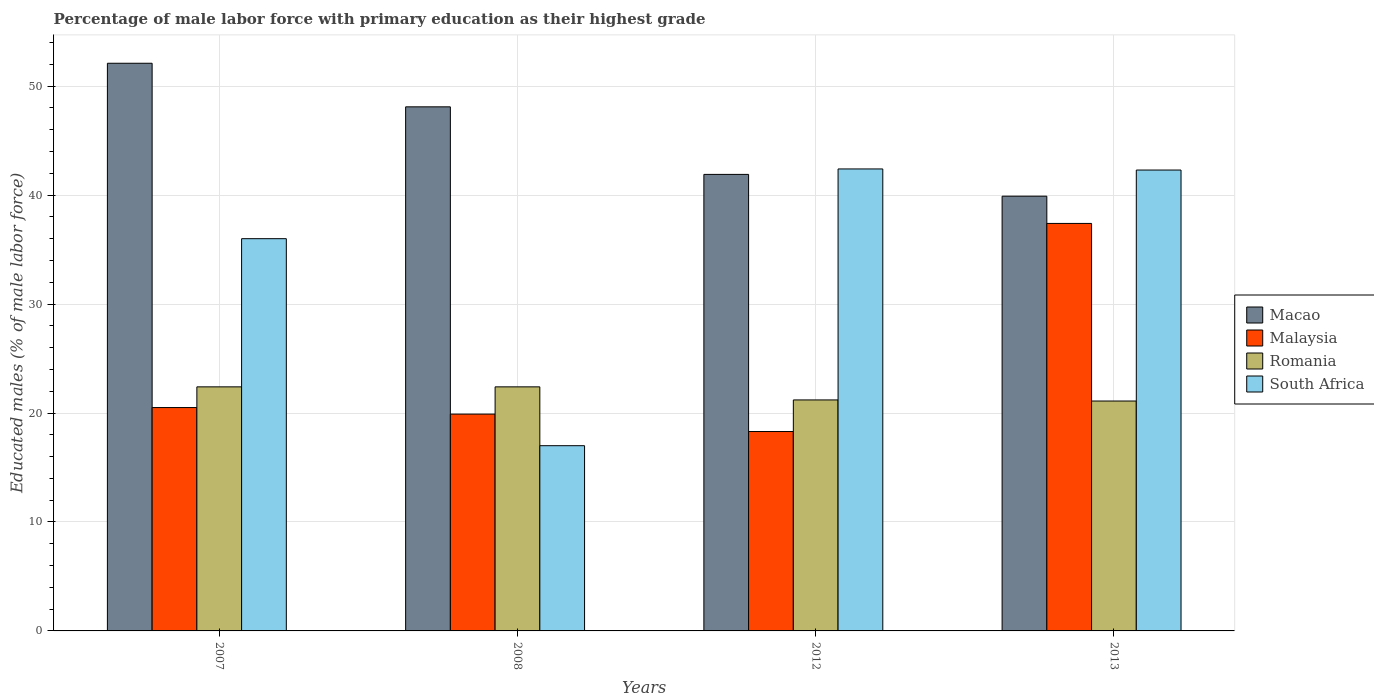Are the number of bars per tick equal to the number of legend labels?
Make the answer very short. Yes. How many bars are there on the 1st tick from the left?
Offer a terse response. 4. What is the label of the 1st group of bars from the left?
Offer a very short reply. 2007. What is the percentage of male labor force with primary education in South Africa in 2012?
Offer a terse response. 42.4. Across all years, what is the maximum percentage of male labor force with primary education in Malaysia?
Your answer should be compact. 37.4. Across all years, what is the minimum percentage of male labor force with primary education in Romania?
Your answer should be compact. 21.1. In which year was the percentage of male labor force with primary education in South Africa maximum?
Your answer should be very brief. 2012. In which year was the percentage of male labor force with primary education in South Africa minimum?
Offer a terse response. 2008. What is the total percentage of male labor force with primary education in Romania in the graph?
Ensure brevity in your answer.  87.1. What is the difference between the percentage of male labor force with primary education in South Africa in 2012 and that in 2013?
Make the answer very short. 0.1. What is the difference between the percentage of male labor force with primary education in Macao in 2007 and the percentage of male labor force with primary education in Malaysia in 2012?
Give a very brief answer. 33.8. What is the average percentage of male labor force with primary education in Malaysia per year?
Provide a short and direct response. 24.03. In the year 2008, what is the difference between the percentage of male labor force with primary education in Romania and percentage of male labor force with primary education in Macao?
Keep it short and to the point. -25.7. What is the ratio of the percentage of male labor force with primary education in South Africa in 2007 to that in 2013?
Your answer should be compact. 0.85. What is the difference between the highest and the lowest percentage of male labor force with primary education in Romania?
Your answer should be compact. 1.3. Is the sum of the percentage of male labor force with primary education in Malaysia in 2008 and 2013 greater than the maximum percentage of male labor force with primary education in Macao across all years?
Provide a short and direct response. Yes. Is it the case that in every year, the sum of the percentage of male labor force with primary education in Malaysia and percentage of male labor force with primary education in Romania is greater than the sum of percentage of male labor force with primary education in South Africa and percentage of male labor force with primary education in Macao?
Give a very brief answer. No. What does the 3rd bar from the left in 2012 represents?
Offer a very short reply. Romania. What does the 1st bar from the right in 2013 represents?
Provide a succinct answer. South Africa. How many bars are there?
Your response must be concise. 16. How many years are there in the graph?
Your response must be concise. 4. What is the difference between two consecutive major ticks on the Y-axis?
Ensure brevity in your answer.  10. Are the values on the major ticks of Y-axis written in scientific E-notation?
Your answer should be very brief. No. Does the graph contain grids?
Your answer should be compact. Yes. Where does the legend appear in the graph?
Ensure brevity in your answer.  Center right. How are the legend labels stacked?
Provide a succinct answer. Vertical. What is the title of the graph?
Provide a short and direct response. Percentage of male labor force with primary education as their highest grade. What is the label or title of the Y-axis?
Ensure brevity in your answer.  Educated males (% of male labor force). What is the Educated males (% of male labor force) of Macao in 2007?
Make the answer very short. 52.1. What is the Educated males (% of male labor force) of Romania in 2007?
Offer a very short reply. 22.4. What is the Educated males (% of male labor force) in Macao in 2008?
Offer a very short reply. 48.1. What is the Educated males (% of male labor force) in Malaysia in 2008?
Offer a terse response. 19.9. What is the Educated males (% of male labor force) of Romania in 2008?
Your answer should be compact. 22.4. What is the Educated males (% of male labor force) of South Africa in 2008?
Provide a short and direct response. 17. What is the Educated males (% of male labor force) in Macao in 2012?
Provide a succinct answer. 41.9. What is the Educated males (% of male labor force) of Malaysia in 2012?
Offer a terse response. 18.3. What is the Educated males (% of male labor force) of Romania in 2012?
Ensure brevity in your answer.  21.2. What is the Educated males (% of male labor force) of South Africa in 2012?
Your answer should be very brief. 42.4. What is the Educated males (% of male labor force) of Macao in 2013?
Offer a terse response. 39.9. What is the Educated males (% of male labor force) of Malaysia in 2013?
Make the answer very short. 37.4. What is the Educated males (% of male labor force) in Romania in 2013?
Your answer should be very brief. 21.1. What is the Educated males (% of male labor force) in South Africa in 2013?
Your answer should be very brief. 42.3. Across all years, what is the maximum Educated males (% of male labor force) of Macao?
Give a very brief answer. 52.1. Across all years, what is the maximum Educated males (% of male labor force) in Malaysia?
Your response must be concise. 37.4. Across all years, what is the maximum Educated males (% of male labor force) in Romania?
Make the answer very short. 22.4. Across all years, what is the maximum Educated males (% of male labor force) in South Africa?
Keep it short and to the point. 42.4. Across all years, what is the minimum Educated males (% of male labor force) of Macao?
Your answer should be very brief. 39.9. Across all years, what is the minimum Educated males (% of male labor force) of Malaysia?
Provide a succinct answer. 18.3. Across all years, what is the minimum Educated males (% of male labor force) in Romania?
Provide a succinct answer. 21.1. What is the total Educated males (% of male labor force) in Macao in the graph?
Give a very brief answer. 182. What is the total Educated males (% of male labor force) in Malaysia in the graph?
Give a very brief answer. 96.1. What is the total Educated males (% of male labor force) in Romania in the graph?
Keep it short and to the point. 87.1. What is the total Educated males (% of male labor force) of South Africa in the graph?
Give a very brief answer. 137.7. What is the difference between the Educated males (% of male labor force) in Macao in 2007 and that in 2008?
Offer a very short reply. 4. What is the difference between the Educated males (% of male labor force) in Malaysia in 2007 and that in 2012?
Your response must be concise. 2.2. What is the difference between the Educated males (% of male labor force) in Romania in 2007 and that in 2012?
Offer a terse response. 1.2. What is the difference between the Educated males (% of male labor force) of Malaysia in 2007 and that in 2013?
Your answer should be very brief. -16.9. What is the difference between the Educated males (% of male labor force) in Romania in 2007 and that in 2013?
Make the answer very short. 1.3. What is the difference between the Educated males (% of male labor force) in South Africa in 2007 and that in 2013?
Offer a very short reply. -6.3. What is the difference between the Educated males (% of male labor force) of Malaysia in 2008 and that in 2012?
Ensure brevity in your answer.  1.6. What is the difference between the Educated males (% of male labor force) in Romania in 2008 and that in 2012?
Make the answer very short. 1.2. What is the difference between the Educated males (% of male labor force) in South Africa in 2008 and that in 2012?
Make the answer very short. -25.4. What is the difference between the Educated males (% of male labor force) of Macao in 2008 and that in 2013?
Ensure brevity in your answer.  8.2. What is the difference between the Educated males (% of male labor force) of Malaysia in 2008 and that in 2013?
Keep it short and to the point. -17.5. What is the difference between the Educated males (% of male labor force) of Romania in 2008 and that in 2013?
Your answer should be compact. 1.3. What is the difference between the Educated males (% of male labor force) of South Africa in 2008 and that in 2013?
Make the answer very short. -25.3. What is the difference between the Educated males (% of male labor force) in Malaysia in 2012 and that in 2013?
Offer a terse response. -19.1. What is the difference between the Educated males (% of male labor force) of South Africa in 2012 and that in 2013?
Offer a very short reply. 0.1. What is the difference between the Educated males (% of male labor force) of Macao in 2007 and the Educated males (% of male labor force) of Malaysia in 2008?
Your answer should be very brief. 32.2. What is the difference between the Educated males (% of male labor force) in Macao in 2007 and the Educated males (% of male labor force) in Romania in 2008?
Make the answer very short. 29.7. What is the difference between the Educated males (% of male labor force) of Macao in 2007 and the Educated males (% of male labor force) of South Africa in 2008?
Provide a succinct answer. 35.1. What is the difference between the Educated males (% of male labor force) in Malaysia in 2007 and the Educated males (% of male labor force) in Romania in 2008?
Your answer should be very brief. -1.9. What is the difference between the Educated males (% of male labor force) in Malaysia in 2007 and the Educated males (% of male labor force) in South Africa in 2008?
Make the answer very short. 3.5. What is the difference between the Educated males (% of male labor force) in Romania in 2007 and the Educated males (% of male labor force) in South Africa in 2008?
Your answer should be compact. 5.4. What is the difference between the Educated males (% of male labor force) in Macao in 2007 and the Educated males (% of male labor force) in Malaysia in 2012?
Your answer should be compact. 33.8. What is the difference between the Educated males (% of male labor force) in Macao in 2007 and the Educated males (% of male labor force) in Romania in 2012?
Keep it short and to the point. 30.9. What is the difference between the Educated males (% of male labor force) in Macao in 2007 and the Educated males (% of male labor force) in South Africa in 2012?
Offer a very short reply. 9.7. What is the difference between the Educated males (% of male labor force) in Malaysia in 2007 and the Educated males (% of male labor force) in South Africa in 2012?
Give a very brief answer. -21.9. What is the difference between the Educated males (% of male labor force) in Romania in 2007 and the Educated males (% of male labor force) in South Africa in 2012?
Offer a terse response. -20. What is the difference between the Educated males (% of male labor force) in Macao in 2007 and the Educated males (% of male labor force) in Malaysia in 2013?
Your response must be concise. 14.7. What is the difference between the Educated males (% of male labor force) of Macao in 2007 and the Educated males (% of male labor force) of Romania in 2013?
Keep it short and to the point. 31. What is the difference between the Educated males (% of male labor force) of Malaysia in 2007 and the Educated males (% of male labor force) of South Africa in 2013?
Ensure brevity in your answer.  -21.8. What is the difference between the Educated males (% of male labor force) of Romania in 2007 and the Educated males (% of male labor force) of South Africa in 2013?
Give a very brief answer. -19.9. What is the difference between the Educated males (% of male labor force) of Macao in 2008 and the Educated males (% of male labor force) of Malaysia in 2012?
Make the answer very short. 29.8. What is the difference between the Educated males (% of male labor force) of Macao in 2008 and the Educated males (% of male labor force) of Romania in 2012?
Give a very brief answer. 26.9. What is the difference between the Educated males (% of male labor force) of Malaysia in 2008 and the Educated males (% of male labor force) of Romania in 2012?
Ensure brevity in your answer.  -1.3. What is the difference between the Educated males (% of male labor force) in Malaysia in 2008 and the Educated males (% of male labor force) in South Africa in 2012?
Your answer should be compact. -22.5. What is the difference between the Educated males (% of male labor force) of Macao in 2008 and the Educated males (% of male labor force) of Romania in 2013?
Offer a very short reply. 27. What is the difference between the Educated males (% of male labor force) in Malaysia in 2008 and the Educated males (% of male labor force) in South Africa in 2013?
Your answer should be compact. -22.4. What is the difference between the Educated males (% of male labor force) in Romania in 2008 and the Educated males (% of male labor force) in South Africa in 2013?
Your response must be concise. -19.9. What is the difference between the Educated males (% of male labor force) of Macao in 2012 and the Educated males (% of male labor force) of Romania in 2013?
Offer a terse response. 20.8. What is the difference between the Educated males (% of male labor force) in Macao in 2012 and the Educated males (% of male labor force) in South Africa in 2013?
Offer a very short reply. -0.4. What is the difference between the Educated males (% of male labor force) of Malaysia in 2012 and the Educated males (% of male labor force) of South Africa in 2013?
Keep it short and to the point. -24. What is the difference between the Educated males (% of male labor force) of Romania in 2012 and the Educated males (% of male labor force) of South Africa in 2013?
Provide a short and direct response. -21.1. What is the average Educated males (% of male labor force) in Macao per year?
Provide a short and direct response. 45.5. What is the average Educated males (% of male labor force) in Malaysia per year?
Offer a terse response. 24.02. What is the average Educated males (% of male labor force) in Romania per year?
Provide a short and direct response. 21.77. What is the average Educated males (% of male labor force) of South Africa per year?
Your answer should be compact. 34.42. In the year 2007, what is the difference between the Educated males (% of male labor force) in Macao and Educated males (% of male labor force) in Malaysia?
Your answer should be compact. 31.6. In the year 2007, what is the difference between the Educated males (% of male labor force) of Macao and Educated males (% of male labor force) of Romania?
Keep it short and to the point. 29.7. In the year 2007, what is the difference between the Educated males (% of male labor force) in Malaysia and Educated males (% of male labor force) in Romania?
Offer a very short reply. -1.9. In the year 2007, what is the difference between the Educated males (% of male labor force) of Malaysia and Educated males (% of male labor force) of South Africa?
Your answer should be very brief. -15.5. In the year 2008, what is the difference between the Educated males (% of male labor force) in Macao and Educated males (% of male labor force) in Malaysia?
Provide a succinct answer. 28.2. In the year 2008, what is the difference between the Educated males (% of male labor force) in Macao and Educated males (% of male labor force) in Romania?
Your answer should be very brief. 25.7. In the year 2008, what is the difference between the Educated males (% of male labor force) in Macao and Educated males (% of male labor force) in South Africa?
Ensure brevity in your answer.  31.1. In the year 2012, what is the difference between the Educated males (% of male labor force) of Macao and Educated males (% of male labor force) of Malaysia?
Make the answer very short. 23.6. In the year 2012, what is the difference between the Educated males (% of male labor force) of Macao and Educated males (% of male labor force) of Romania?
Offer a terse response. 20.7. In the year 2012, what is the difference between the Educated males (% of male labor force) in Macao and Educated males (% of male labor force) in South Africa?
Your response must be concise. -0.5. In the year 2012, what is the difference between the Educated males (% of male labor force) in Malaysia and Educated males (% of male labor force) in Romania?
Provide a short and direct response. -2.9. In the year 2012, what is the difference between the Educated males (% of male labor force) of Malaysia and Educated males (% of male labor force) of South Africa?
Offer a terse response. -24.1. In the year 2012, what is the difference between the Educated males (% of male labor force) of Romania and Educated males (% of male labor force) of South Africa?
Your answer should be very brief. -21.2. In the year 2013, what is the difference between the Educated males (% of male labor force) in Macao and Educated males (% of male labor force) in Malaysia?
Your answer should be compact. 2.5. In the year 2013, what is the difference between the Educated males (% of male labor force) in Malaysia and Educated males (% of male labor force) in South Africa?
Make the answer very short. -4.9. In the year 2013, what is the difference between the Educated males (% of male labor force) in Romania and Educated males (% of male labor force) in South Africa?
Ensure brevity in your answer.  -21.2. What is the ratio of the Educated males (% of male labor force) of Macao in 2007 to that in 2008?
Give a very brief answer. 1.08. What is the ratio of the Educated males (% of male labor force) of Malaysia in 2007 to that in 2008?
Your answer should be very brief. 1.03. What is the ratio of the Educated males (% of male labor force) in Romania in 2007 to that in 2008?
Your answer should be compact. 1. What is the ratio of the Educated males (% of male labor force) of South Africa in 2007 to that in 2008?
Provide a succinct answer. 2.12. What is the ratio of the Educated males (% of male labor force) in Macao in 2007 to that in 2012?
Keep it short and to the point. 1.24. What is the ratio of the Educated males (% of male labor force) in Malaysia in 2007 to that in 2012?
Your response must be concise. 1.12. What is the ratio of the Educated males (% of male labor force) in Romania in 2007 to that in 2012?
Your answer should be very brief. 1.06. What is the ratio of the Educated males (% of male labor force) in South Africa in 2007 to that in 2012?
Ensure brevity in your answer.  0.85. What is the ratio of the Educated males (% of male labor force) of Macao in 2007 to that in 2013?
Make the answer very short. 1.31. What is the ratio of the Educated males (% of male labor force) of Malaysia in 2007 to that in 2013?
Give a very brief answer. 0.55. What is the ratio of the Educated males (% of male labor force) in Romania in 2007 to that in 2013?
Your answer should be very brief. 1.06. What is the ratio of the Educated males (% of male labor force) of South Africa in 2007 to that in 2013?
Offer a terse response. 0.85. What is the ratio of the Educated males (% of male labor force) in Macao in 2008 to that in 2012?
Provide a succinct answer. 1.15. What is the ratio of the Educated males (% of male labor force) of Malaysia in 2008 to that in 2012?
Your answer should be very brief. 1.09. What is the ratio of the Educated males (% of male labor force) of Romania in 2008 to that in 2012?
Your response must be concise. 1.06. What is the ratio of the Educated males (% of male labor force) of South Africa in 2008 to that in 2012?
Give a very brief answer. 0.4. What is the ratio of the Educated males (% of male labor force) in Macao in 2008 to that in 2013?
Give a very brief answer. 1.21. What is the ratio of the Educated males (% of male labor force) in Malaysia in 2008 to that in 2013?
Your answer should be very brief. 0.53. What is the ratio of the Educated males (% of male labor force) in Romania in 2008 to that in 2013?
Make the answer very short. 1.06. What is the ratio of the Educated males (% of male labor force) of South Africa in 2008 to that in 2013?
Make the answer very short. 0.4. What is the ratio of the Educated males (% of male labor force) in Macao in 2012 to that in 2013?
Offer a terse response. 1.05. What is the ratio of the Educated males (% of male labor force) of Malaysia in 2012 to that in 2013?
Your answer should be very brief. 0.49. What is the difference between the highest and the second highest Educated males (% of male labor force) in Romania?
Your answer should be very brief. 0. What is the difference between the highest and the second highest Educated males (% of male labor force) in South Africa?
Your answer should be very brief. 0.1. What is the difference between the highest and the lowest Educated males (% of male labor force) of South Africa?
Ensure brevity in your answer.  25.4. 